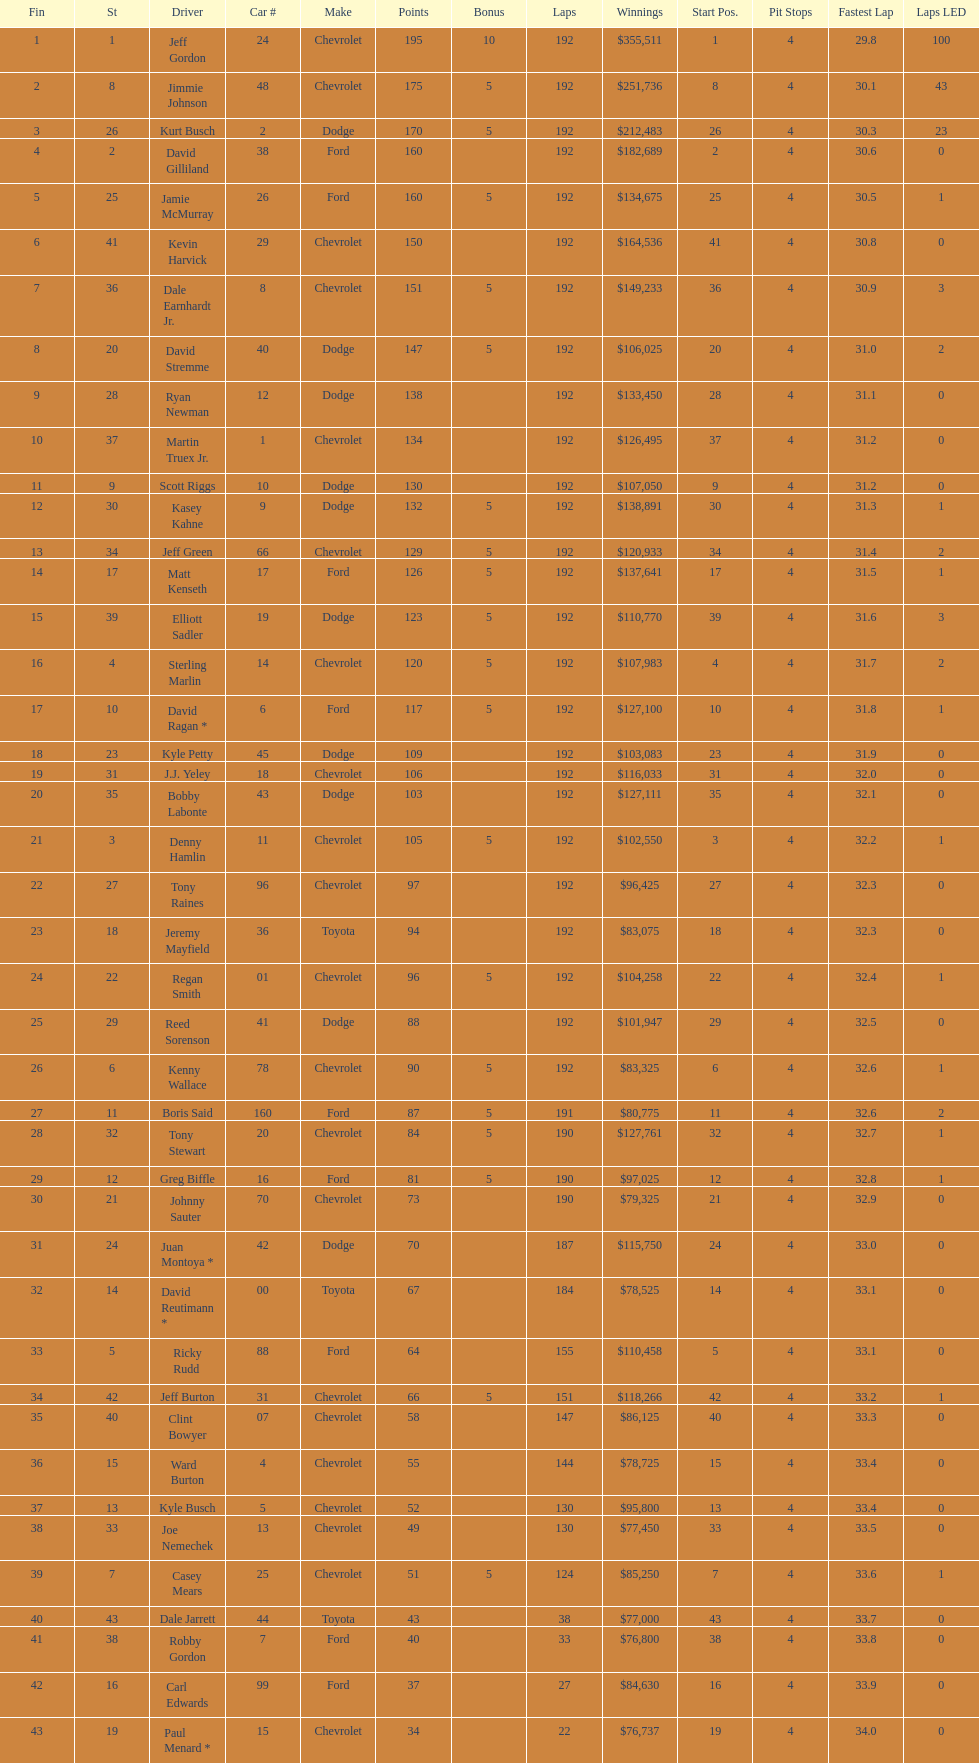Who got the most bonus points? Jeff Gordon. 